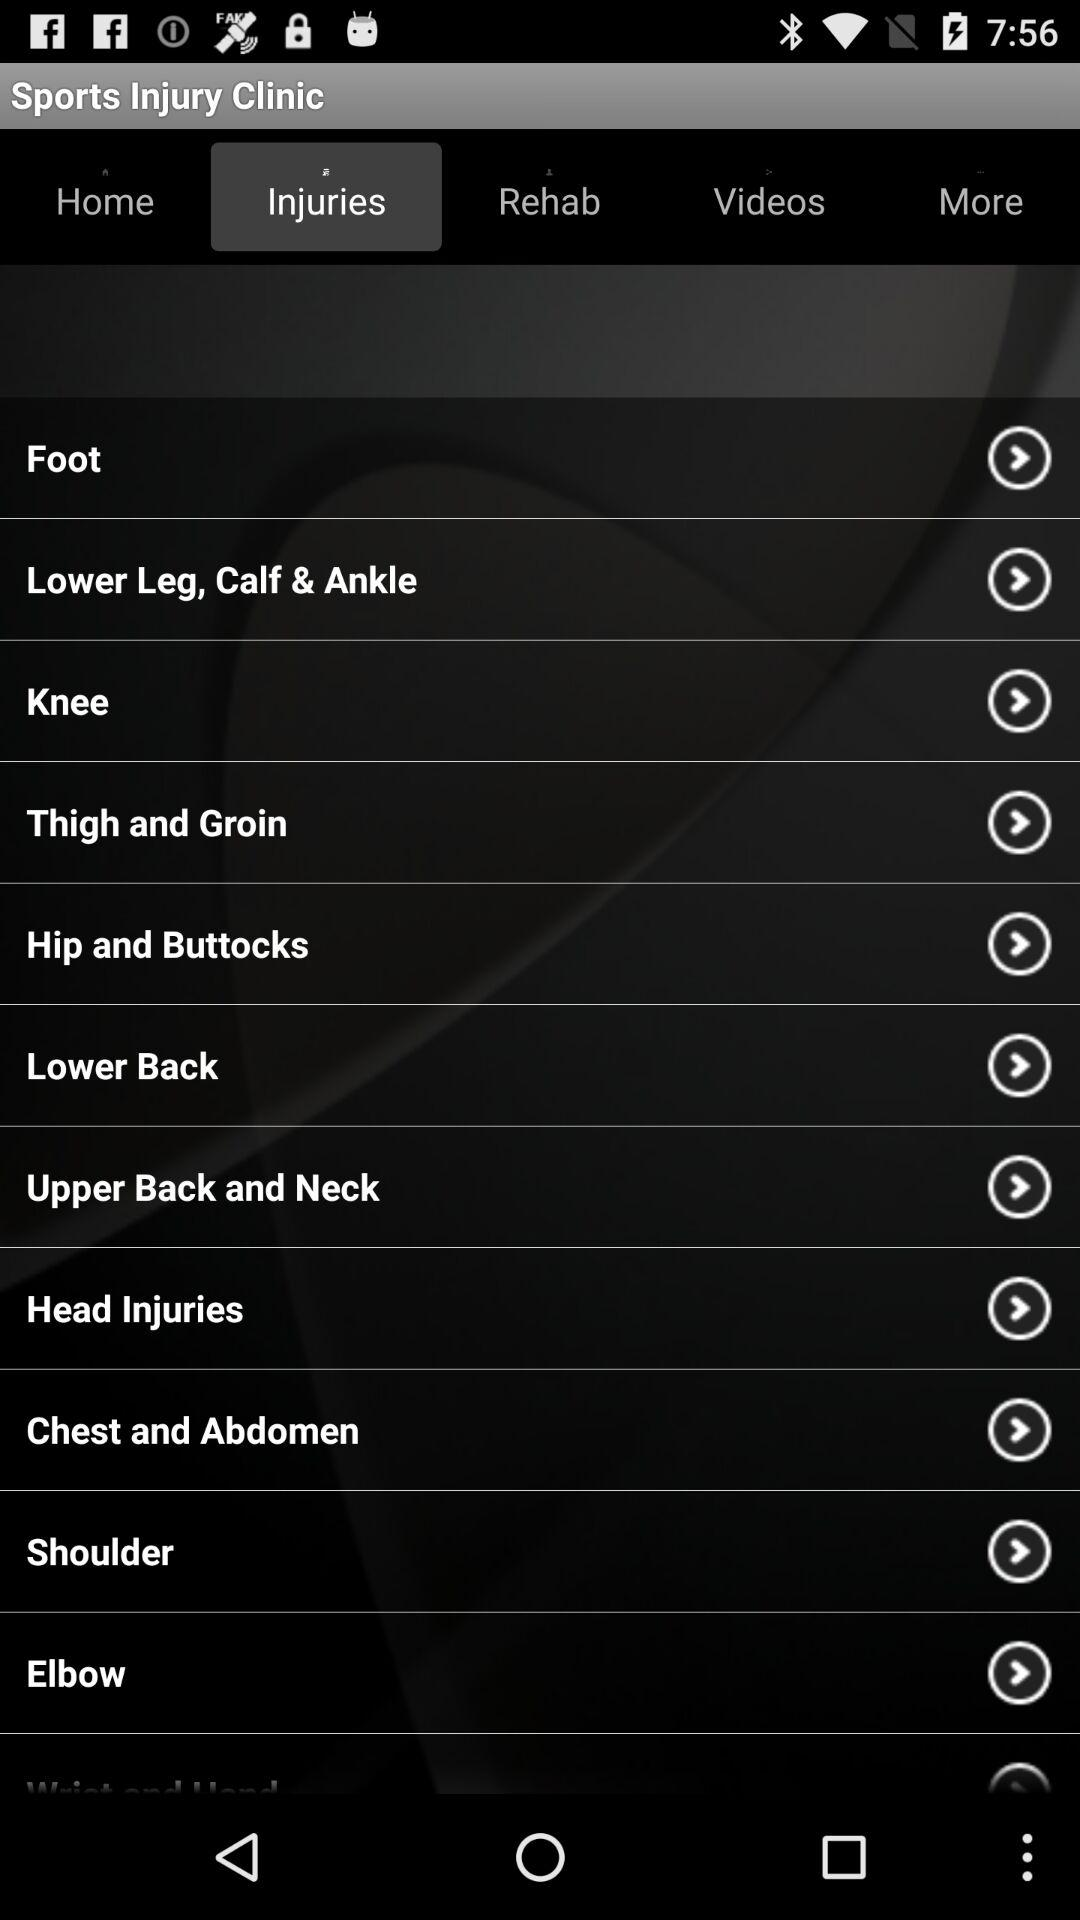What is the name of the application? The name of the application is "Sports Injury Clinic". 